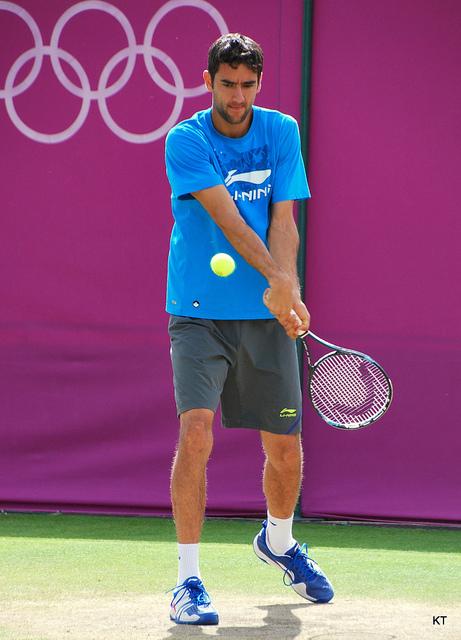What symbol is on the pink wall?
Answer briefly. Olympics. Is the man abusing the tennis ball?
Give a very brief answer. No. What letter is on the racket?
Give a very brief answer. U. Is he holding the racket with both hands?
Keep it brief. Yes. Where are the blue shoe strings?
Write a very short answer. On shoes. What brand name is on the shirt?
Be succinct. Nike. What color are the socks?
Short answer required. White. What brand is his racquet?
Write a very short answer. Wilson. What is the man about to do?
Short answer required. Hit ball. 